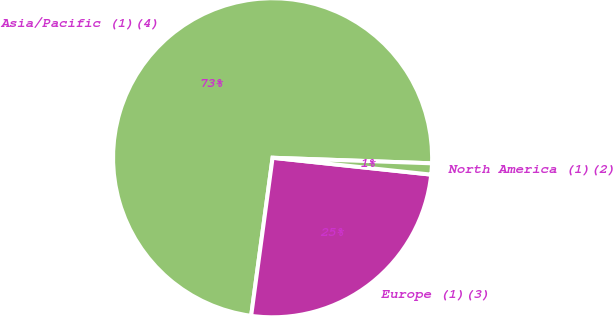Convert chart. <chart><loc_0><loc_0><loc_500><loc_500><pie_chart><fcel>Asia/Pacific (1)(4)<fcel>Europe (1)(3)<fcel>North America (1)(2)<nl><fcel>73.41%<fcel>25.46%<fcel>1.13%<nl></chart> 